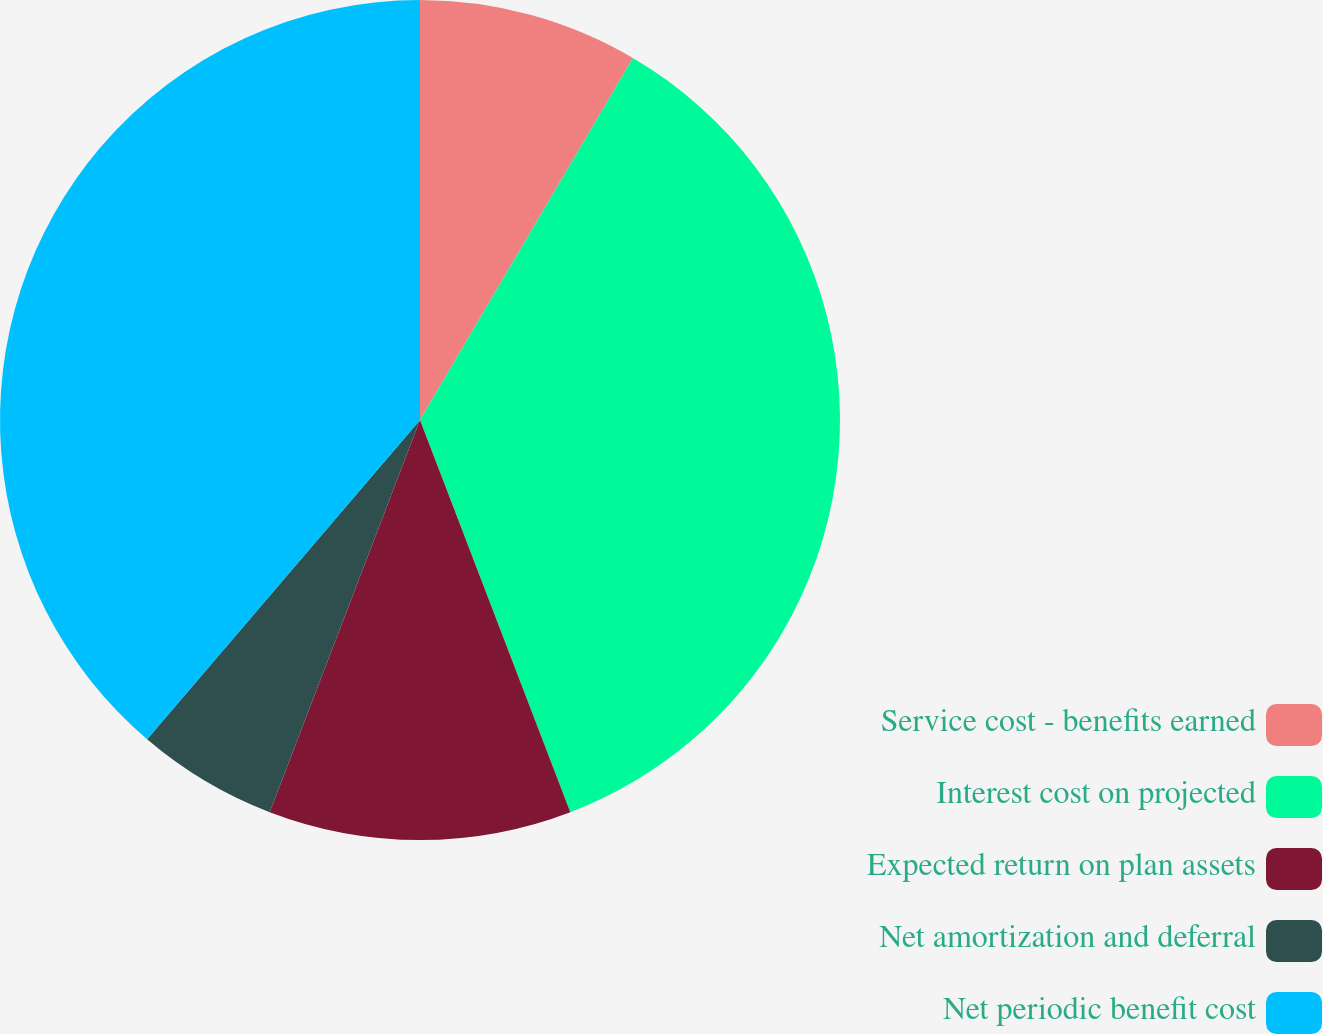Convert chart to OTSL. <chart><loc_0><loc_0><loc_500><loc_500><pie_chart><fcel>Service cost - benefits earned<fcel>Interest cost on projected<fcel>Expected return on plan assets<fcel>Net amortization and deferral<fcel>Net periodic benefit cost<nl><fcel>8.46%<fcel>35.71%<fcel>11.65%<fcel>5.43%<fcel>38.74%<nl></chart> 